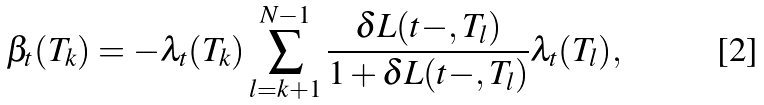<formula> <loc_0><loc_0><loc_500><loc_500>\beta _ { t } ( T _ { k } ) & = - \lambda _ { t } ( T _ { k } ) \sum _ { l = k + 1 } ^ { N - 1 } \frac { \delta L ( t - , T _ { l } ) } { 1 + \delta L ( t - , T _ { l } ) } \lambda _ { t } ( T _ { l } ) ,</formula> 